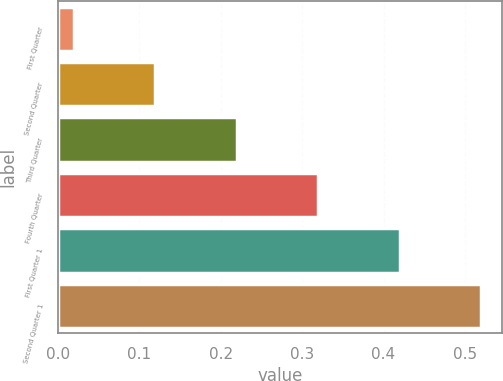Convert chart to OTSL. <chart><loc_0><loc_0><loc_500><loc_500><bar_chart><fcel>First Quarter<fcel>Second Quarter<fcel>Third Quarter<fcel>Fourth Quarter<fcel>First Quarter 1<fcel>Second Quarter 1<nl><fcel>0.02<fcel>0.12<fcel>0.22<fcel>0.32<fcel>0.42<fcel>0.52<nl></chart> 